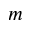<formula> <loc_0><loc_0><loc_500><loc_500>m</formula> 